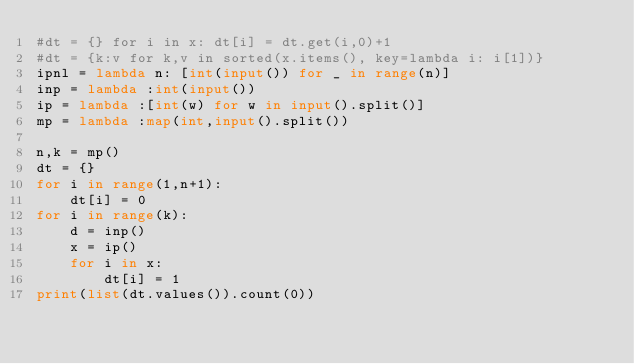<code> <loc_0><loc_0><loc_500><loc_500><_Python_>#dt = {} for i in x: dt[i] = dt.get(i,0)+1
#dt = {k:v for k,v in sorted(x.items(), key=lambda i: i[1])}
ipnl = lambda n: [int(input()) for _ in range(n)]
inp = lambda :int(input())
ip = lambda :[int(w) for w in input().split()]
mp = lambda :map(int,input().split())

n,k = mp()
dt = {}
for i in range(1,n+1):
    dt[i] = 0
for i in range(k):
    d = inp()
    x = ip()
    for i in x:
        dt[i] = 1
print(list(dt.values()).count(0))</code> 